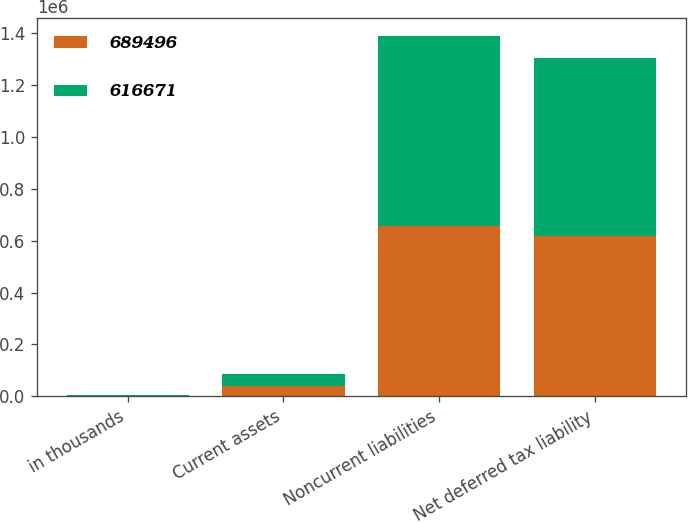Convert chart. <chart><loc_0><loc_0><loc_500><loc_500><stacked_bar_chart><ecel><fcel>in thousands<fcel>Current assets<fcel>Noncurrent liabilities<fcel>Net deferred tax liability<nl><fcel>689496<fcel>2012<fcel>40696<fcel>657367<fcel>616671<nl><fcel>616671<fcel>2011<fcel>43032<fcel>732528<fcel>689496<nl></chart> 